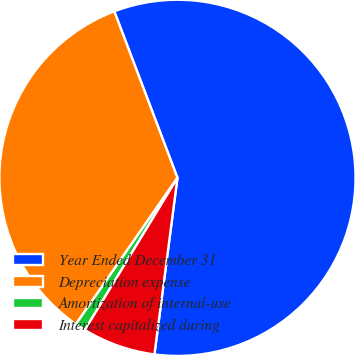Convert chart to OTSL. <chart><loc_0><loc_0><loc_500><loc_500><pie_chart><fcel>Year Ended December 31<fcel>Depreciation expense<fcel>Amortization of internal-use<fcel>Interest capitalized during<nl><fcel>57.84%<fcel>34.58%<fcel>0.95%<fcel>6.64%<nl></chart> 